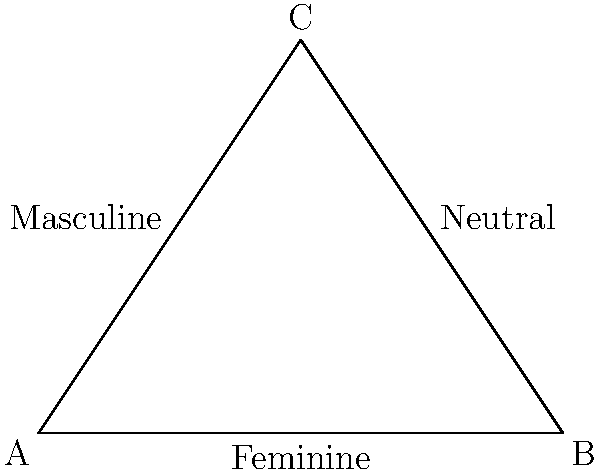In a study on gendered language and spatial reasoning, participants were asked to describe the geometric shape above using either feminine, masculine, or neutral language. If the probability of using feminine language is proportional to the length of side AB, masculine to AC, and neutral to BC, what is the probability of a participant using neutral language to describe the shape? To solve this problem, we need to follow these steps:

1. Calculate the lengths of all sides of the triangle:
   AB: $\sqrt{(4-0)^2 + (0-0)^2} = 4$
   AC: $\sqrt{(2-0)^2 + (3-0)^2} = \sqrt{13}$
   BC: $\sqrt{(2-4)^2 + (3-0)^2} = \sqrt{13}$

2. Calculate the total length of all sides:
   Total length = $4 + \sqrt{13} + \sqrt{13} = 4 + 2\sqrt{13}$

3. Calculate the probability of using neutral language:
   P(neutral) = $\frac{BC}{AB + AC + BC} = \frac{\sqrt{13}}{4 + 2\sqrt{13}}$

4. Simplify the fraction:
   $\frac{\sqrt{13}}{4 + 2\sqrt{13}} = \frac{\sqrt{13}}{4 + 2\sqrt{13}} \cdot \frac{4 - 2\sqrt{13}}{4 - 2\sqrt{13}}$
   $= \frac{4\sqrt{13} - 26}{16 - 52} = \frac{4\sqrt{13} - 26}{-36} = \frac{13 - 2\sqrt{13}}{18}$

Therefore, the probability of a participant using neutral language to describe the shape is $\frac{13 - 2\sqrt{13}}{18}$.
Answer: $\frac{13 - 2\sqrt{13}}{18}$ 